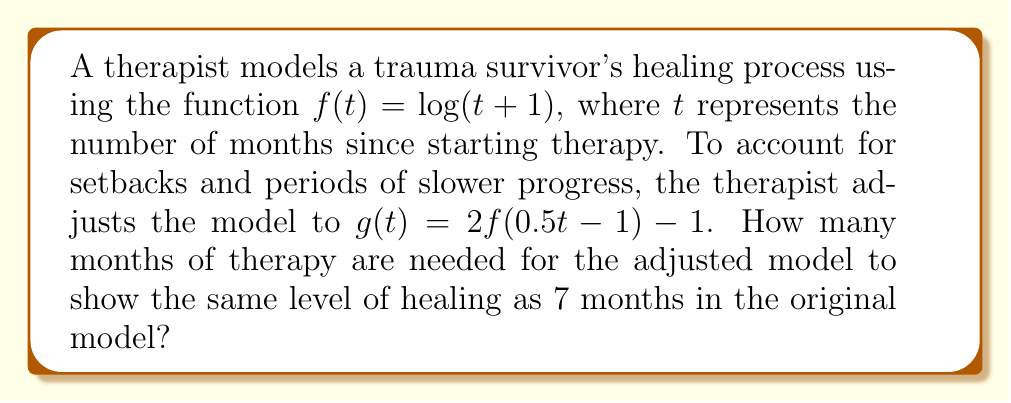Can you solve this math problem? Let's approach this step-by-step:

1) We need to find $t$ such that $g(t) = f(7)$

2) First, let's calculate $f(7)$:
   $f(7) = \log(7+1) = \log(8) = 3$

3) Now, we set up the equation:
   $g(t) = f(7)$
   $2f(0.5t - 1) - 1 = 3$

4) Let's solve for $f(0.5t - 1)$:
   $2f(0.5t - 1) - 1 = 3$
   $2f(0.5t - 1) = 4$
   $f(0.5t - 1) = 2$

5) We know that $f(x) = \log(x+1)$, so:
   $\log((0.5t - 1) + 1) = 2$
   $\log(0.5t) = 2$

6) Solve for $t$:
   $0.5t = e^2$
   $t = 2e^2 \approx 14.78$

7) Since $t$ represents months, we round up to the nearest whole month.
Answer: 15 months 